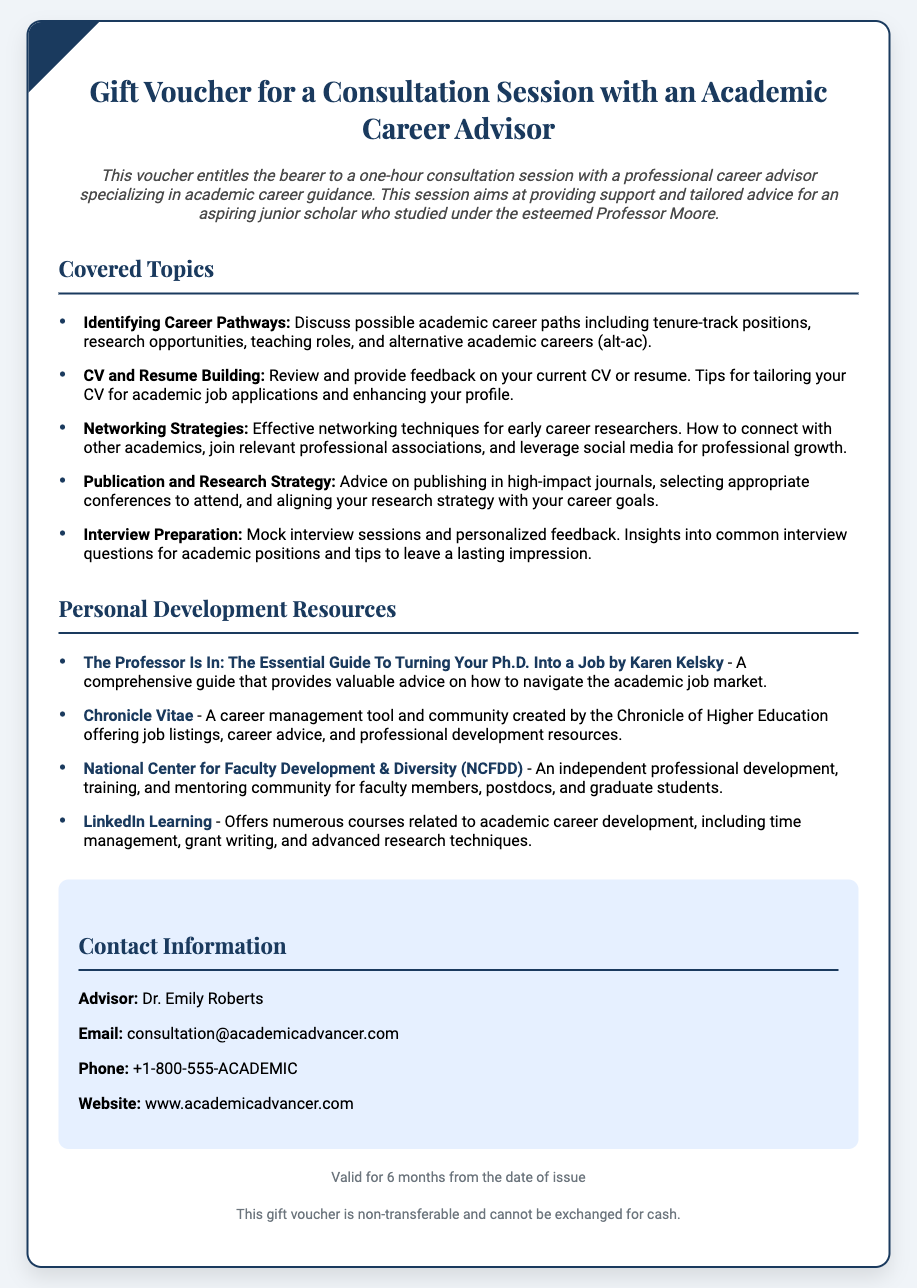What is the title of the gift voucher? The title is the main heading at the top of the document that describes the content of the voucher.
Answer: Gift Voucher for a Consultation Session with an Academic Career Advisor Who is the advisor mentioned in the document? This information is found in the contact information section of the document where the advisor's name is listed.
Answer: Dr. Emily Roberts What is one resource mentioned for personal development? Resources are listed under the Personal Development Resources section, which provides specific titles or names of tools relevant to academic career development.
Answer: The Professor Is In: The Essential Guide To Turning Your Ph.D. Into a Job by Karen Kelsky How long is the voucher valid? The validity period is specified at the end of the document, indicating how long the voucher can be used.
Answer: 6 months What type of session does the voucher entitle the bearer to? This is found in the description section where the type of session is clearly stated.
Answer: Consultation session List one topic covered during the session. Topics are listed under the Covered Topics heading where specific areas of discussion are highlighted.
Answer: Identifying Career Pathways What is the contact email for the advisor? The email address is provided in the contact information section for reaching out to the advisor.
Answer: consultation@academicadvancer.com Is the gift voucher transferable? The information regarding the transferability of the voucher is mentioned in the disclaimer section at the end of the document.
Answer: No 